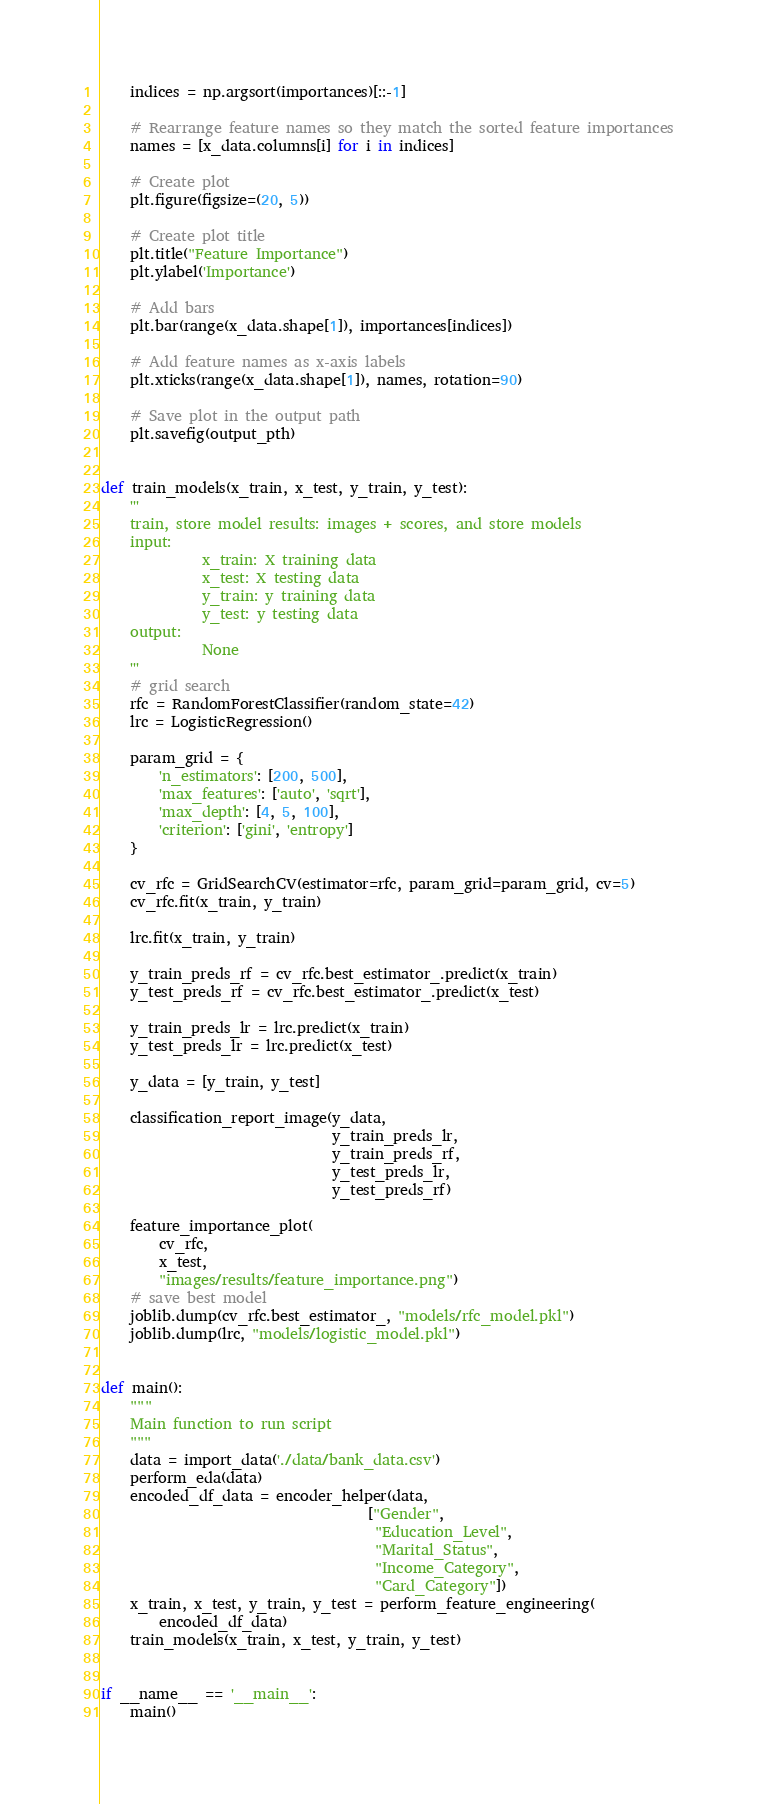<code> <loc_0><loc_0><loc_500><loc_500><_Python_>    indices = np.argsort(importances)[::-1]

    # Rearrange feature names so they match the sorted feature importances
    names = [x_data.columns[i] for i in indices]

    # Create plot
    plt.figure(figsize=(20, 5))

    # Create plot title
    plt.title("Feature Importance")
    plt.ylabel('Importance')

    # Add bars
    plt.bar(range(x_data.shape[1]), importances[indices])

    # Add feature names as x-axis labels
    plt.xticks(range(x_data.shape[1]), names, rotation=90)

    # Save plot in the output path
    plt.savefig(output_pth)


def train_models(x_train, x_test, y_train, y_test):
    '''
    train, store model results: images + scores, and store models
    input:
              x_train: X training data
              x_test: X testing data
              y_train: y training data
              y_test: y testing data
    output:
              None
    '''
    # grid search
    rfc = RandomForestClassifier(random_state=42)
    lrc = LogisticRegression()

    param_grid = {
        'n_estimators': [200, 500],
        'max_features': ['auto', 'sqrt'],
        'max_depth': [4, 5, 100],
        'criterion': ['gini', 'entropy']
    }

    cv_rfc = GridSearchCV(estimator=rfc, param_grid=param_grid, cv=5)
    cv_rfc.fit(x_train, y_train)

    lrc.fit(x_train, y_train)

    y_train_preds_rf = cv_rfc.best_estimator_.predict(x_train)
    y_test_preds_rf = cv_rfc.best_estimator_.predict(x_test)

    y_train_preds_lr = lrc.predict(x_train)
    y_test_preds_lr = lrc.predict(x_test)

    y_data = [y_train, y_test]

    classification_report_image(y_data,
                                y_train_preds_lr,
                                y_train_preds_rf,
                                y_test_preds_lr,
                                y_test_preds_rf)

    feature_importance_plot(
        cv_rfc,
        x_test,
        "images/results/feature_importance.png")
    # save best model
    joblib.dump(cv_rfc.best_estimator_, "models/rfc_model.pkl")
    joblib.dump(lrc, "models/logistic_model.pkl")


def main():
    """
    Main function to run script
    """
    data = import_data('./data/bank_data.csv')
    perform_eda(data)
    encoded_df_data = encoder_helper(data,
                                     ["Gender",
                                      "Education_Level",
                                      "Marital_Status",
                                      "Income_Category",
                                      "Card_Category"])
    x_train, x_test, y_train, y_test = perform_feature_engineering(
        encoded_df_data)
    train_models(x_train, x_test, y_train, y_test)


if __name__ == '__main__':
    main()
</code> 